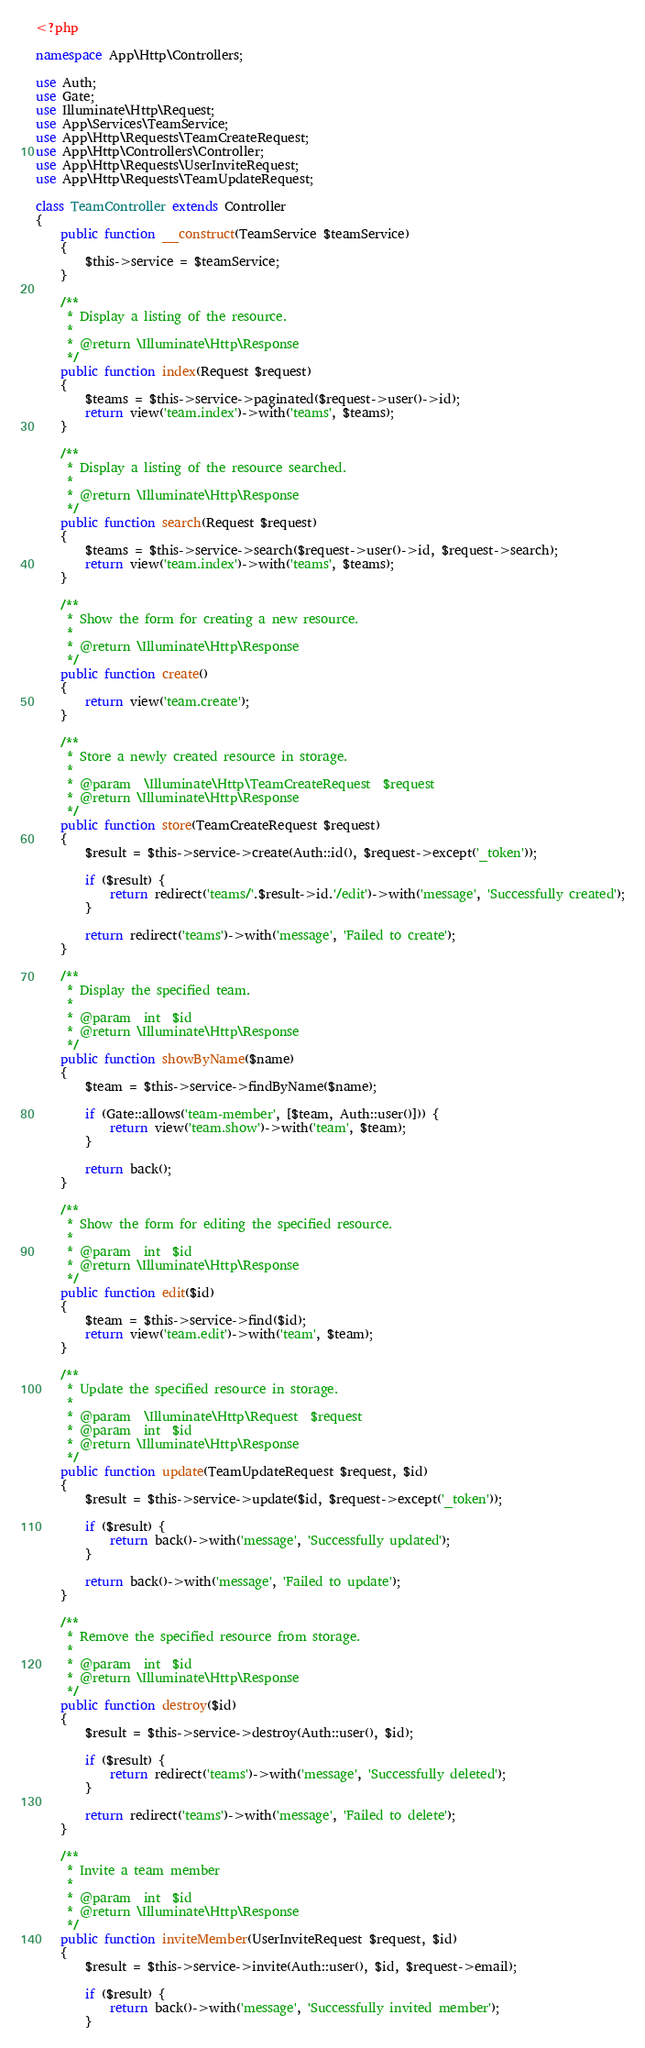Convert code to text. <code><loc_0><loc_0><loc_500><loc_500><_PHP_><?php

namespace App\Http\Controllers;

use Auth;
use Gate;
use Illuminate\Http\Request;
use App\Services\TeamService;
use App\Http\Requests\TeamCreateRequest;
use App\Http\Controllers\Controller;
use App\Http\Requests\UserInviteRequest;
use App\Http\Requests\TeamUpdateRequest;

class TeamController extends Controller
{
    public function __construct(TeamService $teamService)
    {
        $this->service = $teamService;
    }

    /**
     * Display a listing of the resource.
     *
     * @return \Illuminate\Http\Response
     */
    public function index(Request $request)
    {
        $teams = $this->service->paginated($request->user()->id);
        return view('team.index')->with('teams', $teams);
    }

    /**
     * Display a listing of the resource searched.
     *
     * @return \Illuminate\Http\Response
     */
    public function search(Request $request)
    {
        $teams = $this->service->search($request->user()->id, $request->search);
        return view('team.index')->with('teams', $teams);
    }

    /**
     * Show the form for creating a new resource.
     *
     * @return \Illuminate\Http\Response
     */
    public function create()
    {
        return view('team.create');
    }

    /**
     * Store a newly created resource in storage.
     *
     * @param  \Illuminate\Http\TeamCreateRequest  $request
     * @return \Illuminate\Http\Response
     */
    public function store(TeamCreateRequest $request)
    {
        $result = $this->service->create(Auth::id(), $request->except('_token'));

        if ($result) {
            return redirect('teams/'.$result->id.'/edit')->with('message', 'Successfully created');
        }

        return redirect('teams')->with('message', 'Failed to create');
    }

    /**
     * Display the specified team.
     *
     * @param  int  $id
     * @return \Illuminate\Http\Response
     */
    public function showByName($name)
    {
        $team = $this->service->findByName($name);

        if (Gate::allows('team-member', [$team, Auth::user()])) {
            return view('team.show')->with('team', $team);
        }

        return back();
    }

    /**
     * Show the form for editing the specified resource.
     *
     * @param  int  $id
     * @return \Illuminate\Http\Response
     */
    public function edit($id)
    {
        $team = $this->service->find($id);
        return view('team.edit')->with('team', $team);
    }

    /**
     * Update the specified resource in storage.
     *
     * @param  \Illuminate\Http\Request  $request
     * @param  int  $id
     * @return \Illuminate\Http\Response
     */
    public function update(TeamUpdateRequest $request, $id)
    {
        $result = $this->service->update($id, $request->except('_token'));

        if ($result) {
            return back()->with('message', 'Successfully updated');
        }

        return back()->with('message', 'Failed to update');
    }

    /**
     * Remove the specified resource from storage.
     *
     * @param  int  $id
     * @return \Illuminate\Http\Response
     */
    public function destroy($id)
    {
        $result = $this->service->destroy(Auth::user(), $id);

        if ($result) {
            return redirect('teams')->with('message', 'Successfully deleted');
        }

        return redirect('teams')->with('message', 'Failed to delete');
    }

    /**
     * Invite a team member
     *
     * @param  int  $id
     * @return \Illuminate\Http\Response
     */
    public function inviteMember(UserInviteRequest $request, $id)
    {
        $result = $this->service->invite(Auth::user(), $id, $request->email);

        if ($result) {
            return back()->with('message', 'Successfully invited member');
        }
</code> 